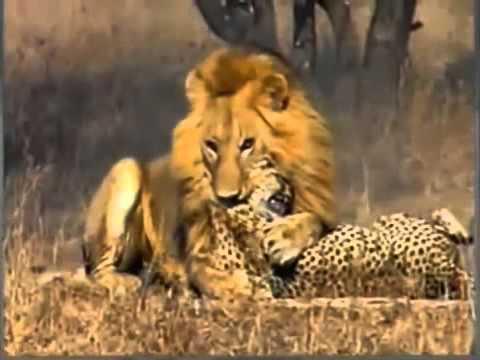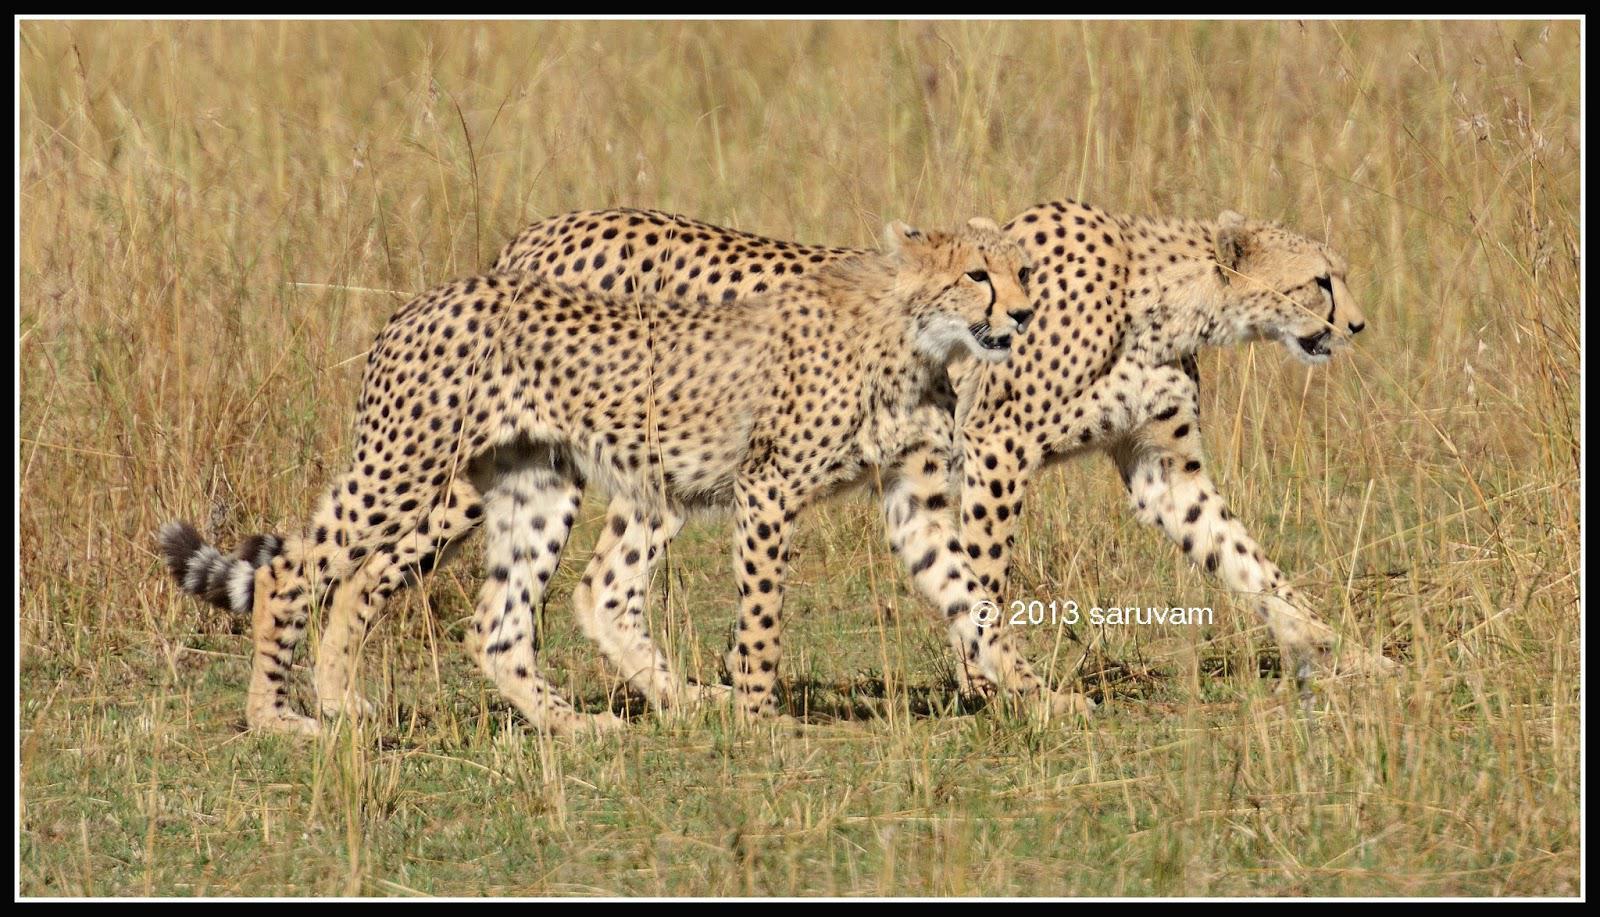The first image is the image on the left, the second image is the image on the right. Examine the images to the left and right. Is the description "An image shows one wild cat with its mouth and paw on the other wild cat." accurate? Answer yes or no. Yes. The first image is the image on the left, the second image is the image on the right. Considering the images on both sides, is "There are a total of 6 or more wild cats." valid? Answer yes or no. No. 